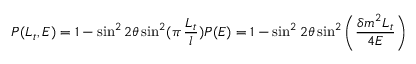Convert formula to latex. <formula><loc_0><loc_0><loc_500><loc_500>P ( L _ { t } , E ) = 1 - \sin ^ { 2 } 2 \theta \sin ^ { 2 } ( \pi \, \frac { L _ { t } } { l } ) P ( E ) = 1 - \sin ^ { 2 } 2 \theta \sin ^ { 2 } \left ( \frac { \delta m ^ { 2 } L _ { t } } { 4 E } \right )</formula> 